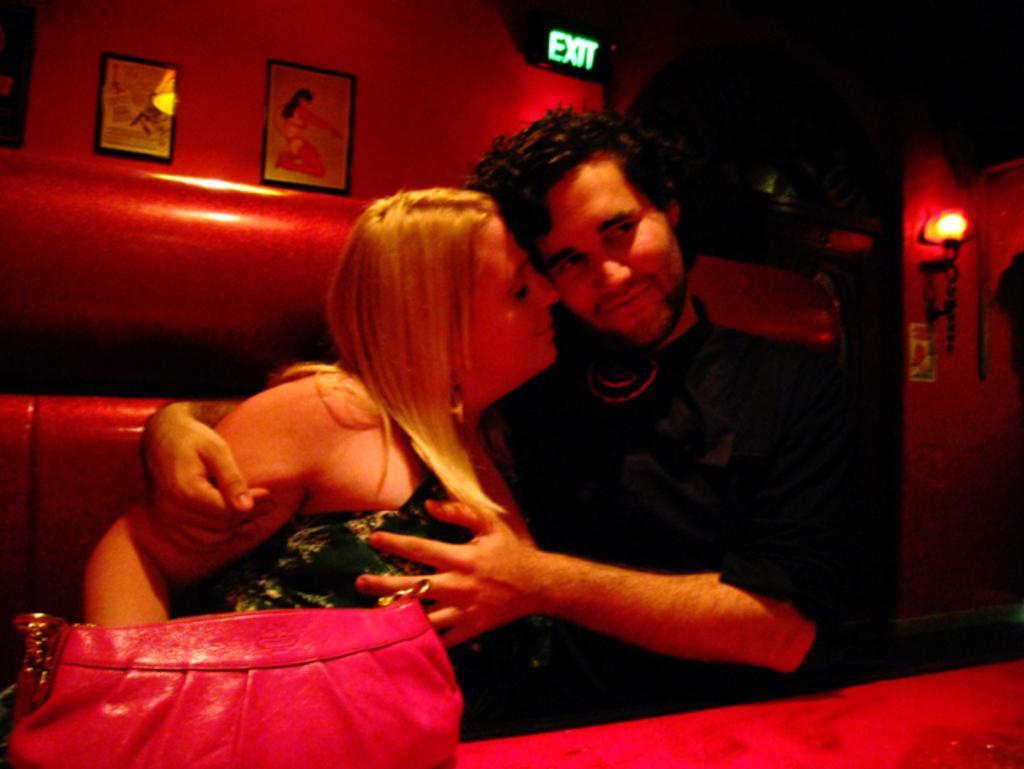How would you summarize this image in a sentence or two? In this picture we can see two people are seated on the sofa in front of them we can find a bag, in the background we can see wall paintings and light. 